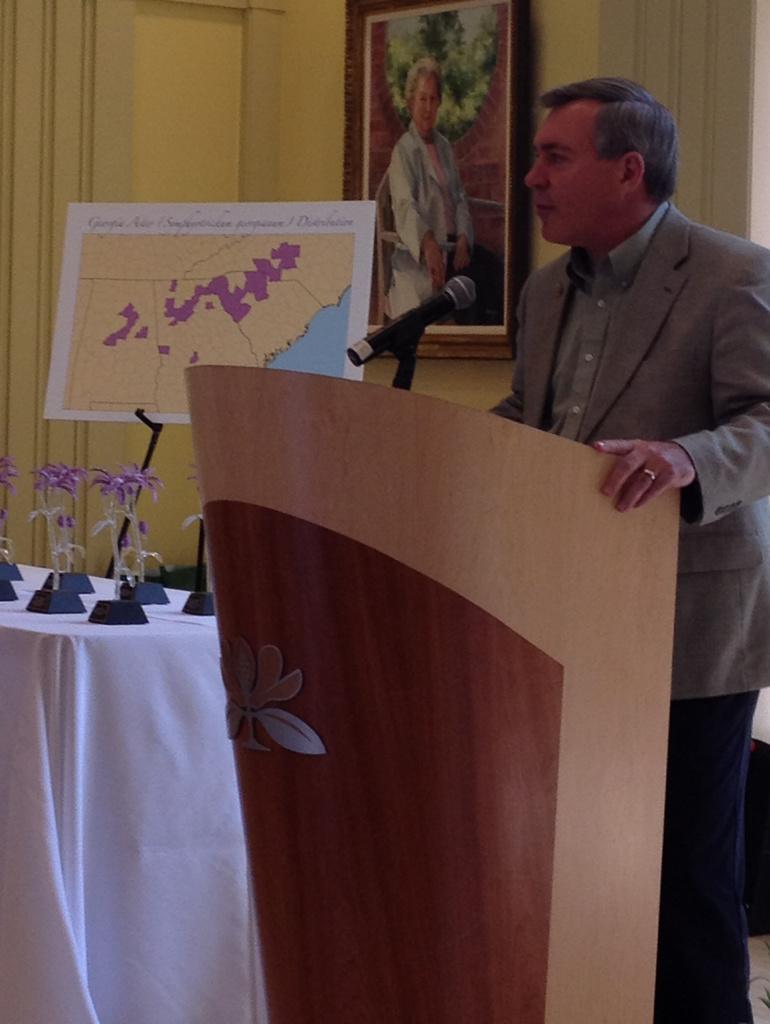Can you describe this image briefly? In this picture we can see a man is standing behind the podium and on the podium there is a microphone with stand. On the left side of the man there is a table which is covered with a white cloth and on the table they are looking like trophies. Behind the trophies there is a board and a wall with a photo frame. 